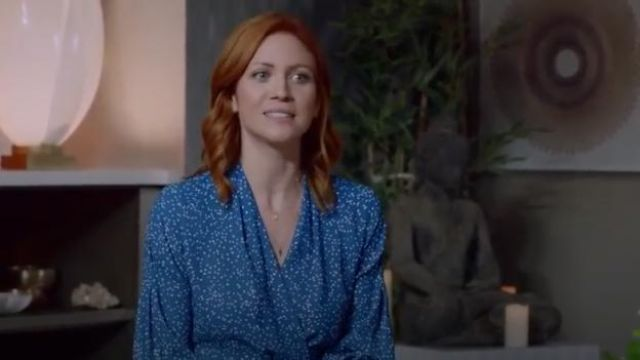Can you describe the setting and its possible significance to the overall mood of the image? Certainly! The living room setting includes minimalist decor, with a soothing color palette dominated by greys and blues. The presence of a plant and soft lighting from the lamp adds to a feeling of tranquility and comfort, enhancing the subject's calm demeanor, potentially suggesting a theme of relaxation and peace in daily life. 